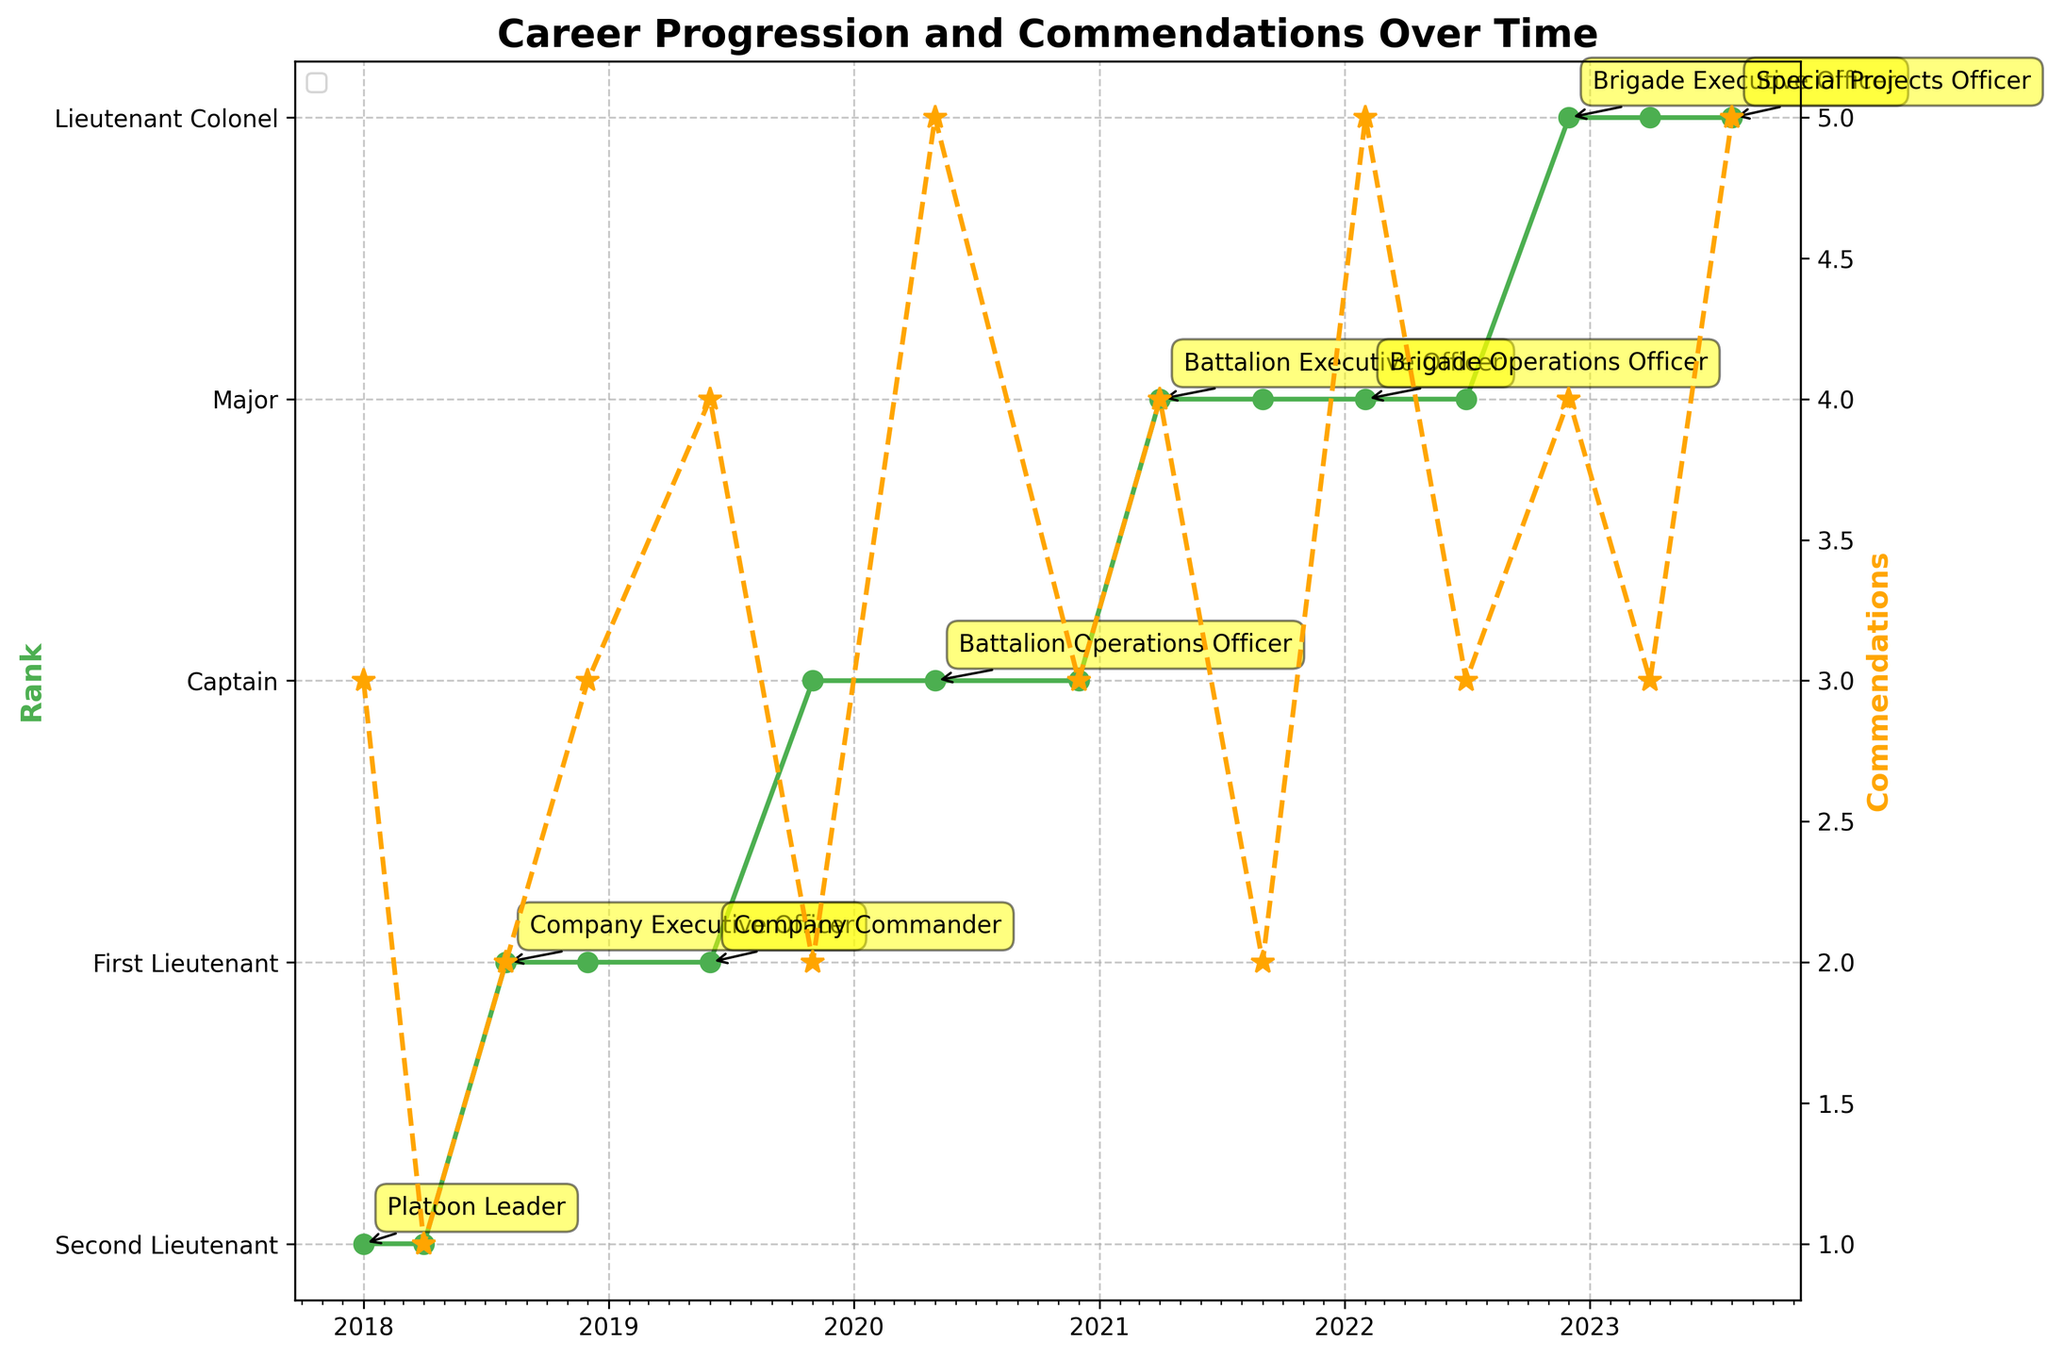what is the title of the figure? The title of the plot is usually located at the top and it summarizes the main idea of the figure. In this case, the title is "Career Progression and Commendations Over Time."
Answer: Career Progression and Commendations Over Time Which rank does the y-axis on the left start with? The y-axis on the left represents the rank progression, with the lowest rank starting at "Second Lieutenant."
Answer: Second Lieutenant How many commendations were given out on 2020-05-01? To find the number of commendations given on 2020-05-01, look for the data point with a star marker on the orange dashed line corresponding to the date 2020-05-01, which shows the value.
Answer: 5 On how many different military bases was the individual stationed? We can see the annotations for location changes in the plot. The person was stationed at Fort Bragg, Fort Benning, Fort Bliss, and the Pentagon. Counting these unique locations gives four military bases.
Answer: 4 Which rank did the individual hold for the longest period? To determine the longest period, look at the green line representing rank progression. The interval with the flattest segment (no change) indicates the longest period. The individual held the rank of "Major" from early 2021 to late 2022, making it the longest duration compared to other ranks.
Answer: Major Compare the number of commendations in 2019-06-01 and 2022-07-01. Which date had more commendations? To compare commendations on these dates, check the star markers for these specific dates. 2019-06-01 had 4 commendations, and 2022-07-01 had 3 commendations. Thus, 2019-06-01 had more commendations.
Answer: 2019-06-01 What was the rank and position as of 2023-08-01? Look at the data point on 2023-08-01, and refer to the green markers for the rank and the annotation for the position. The rank is "Lieutenant Colonel," and the position is "Special Projects Officer."
Answer: Lieutenant Colonel, Special Projects Officer What's the average number of commendations received per year from 2018 to 2023? To calculate the average, sum all the commendations from 2018 to 2023 (3 + 1 + 2 + 3 + 4 + 2 + 5 + 3 + 4 + 2 + 5 + 3 + 4 + 3 + 5 = 45) and divide by the number of years (6). The average is 45/6 = 7.5.
Answer: 7.5 What's the general trend of commendations over the past five years? Observing the orange dashed line, it shows some fluctuations but generally indicates an upward trend as the person's career progresses.
Answer: Upward trend 